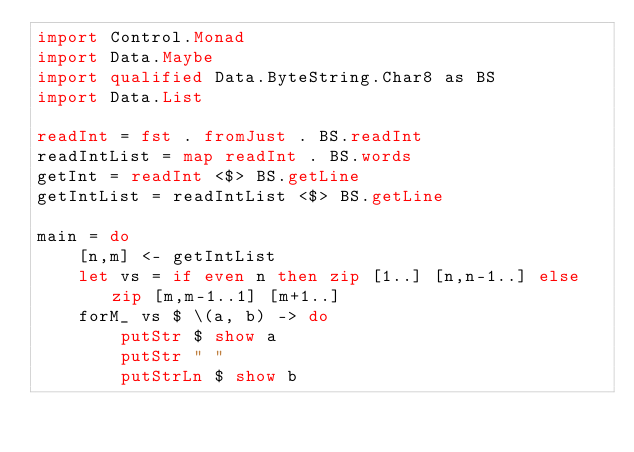<code> <loc_0><loc_0><loc_500><loc_500><_Haskell_>import Control.Monad
import Data.Maybe
import qualified Data.ByteString.Char8 as BS
import Data.List

readInt = fst . fromJust . BS.readInt
readIntList = map readInt . BS.words
getInt = readInt <$> BS.getLine
getIntList = readIntList <$> BS.getLine

main = do
    [n,m] <- getIntList
    let vs = if even n then zip [1..] [n,n-1..] else zip [m,m-1..1] [m+1..]
    forM_ vs $ \(a, b) -> do
        putStr $ show a
        putStr " "
        putStrLn $ show b</code> 